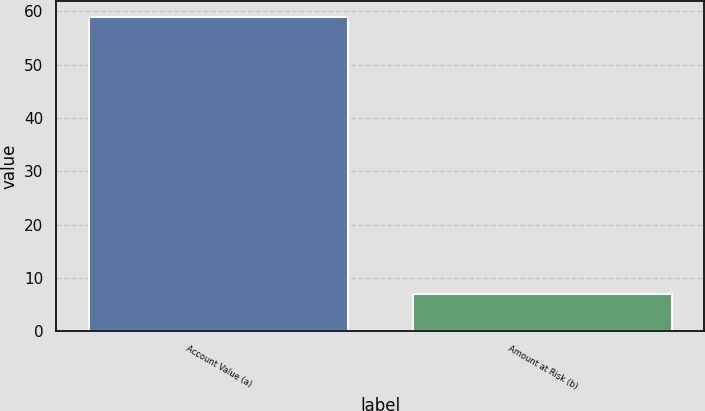<chart> <loc_0><loc_0><loc_500><loc_500><bar_chart><fcel>Account Value (a)<fcel>Amount at Risk (b)<nl><fcel>59<fcel>7<nl></chart> 